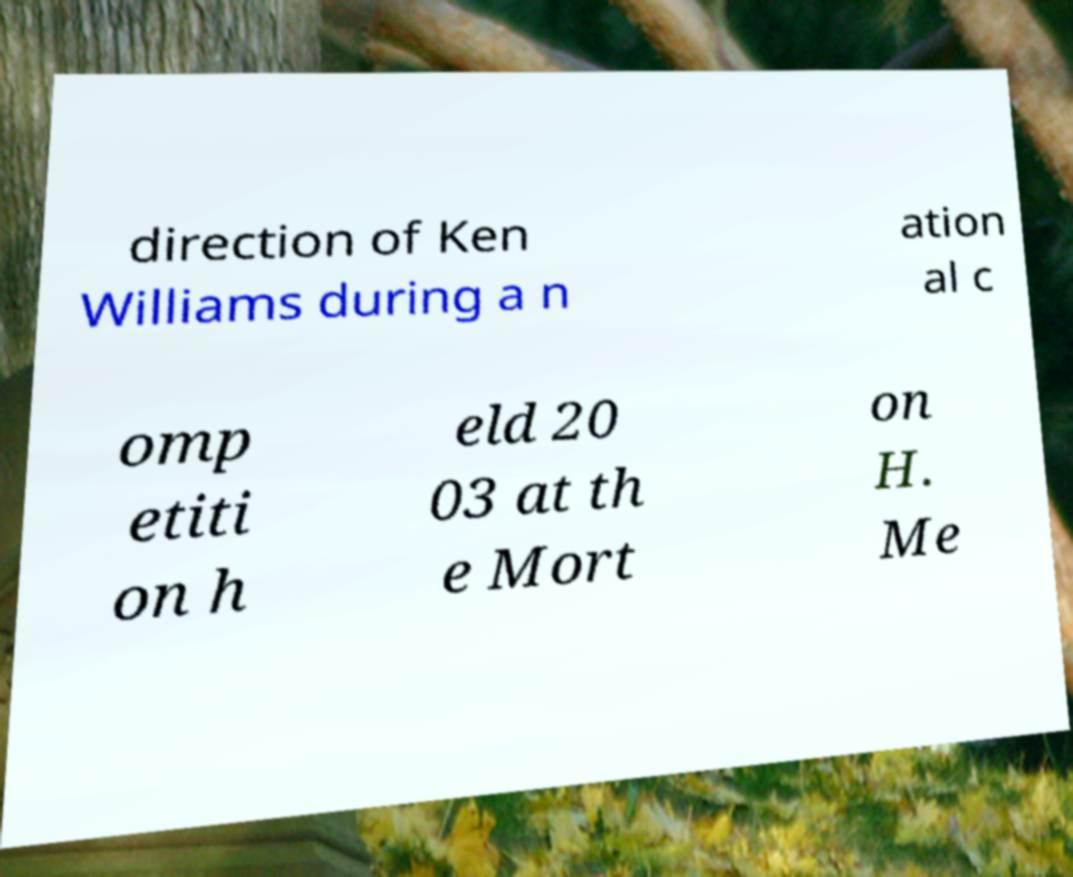Can you read and provide the text displayed in the image?This photo seems to have some interesting text. Can you extract and type it out for me? direction of Ken Williams during a n ation al c omp etiti on h eld 20 03 at th e Mort on H. Me 